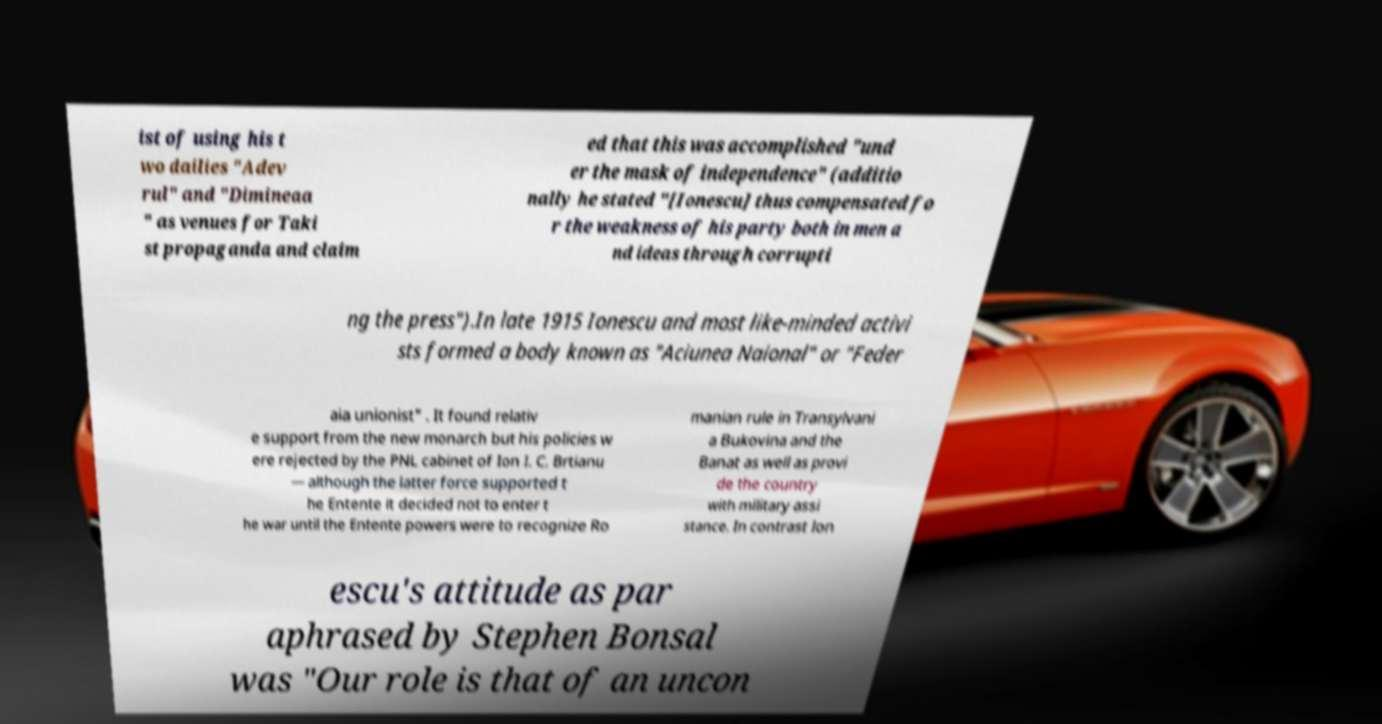Please read and relay the text visible in this image. What does it say? ist of using his t wo dailies "Adev rul" and "Dimineaa " as venues for Taki st propaganda and claim ed that this was accomplished "und er the mask of independence" (additio nally he stated "[Ionescu] thus compensated fo r the weakness of his party both in men a nd ideas through corrupti ng the press").In late 1915 Ionescu and most like-minded activi sts formed a body known as "Aciunea Naional" or "Feder aia unionist" . It found relativ e support from the new monarch but his policies w ere rejected by the PNL cabinet of Ion I. C. Brtianu — although the latter force supported t he Entente it decided not to enter t he war until the Entente powers were to recognize Ro manian rule in Transylvani a Bukovina and the Banat as well as provi de the country with military assi stance. In contrast Ion escu's attitude as par aphrased by Stephen Bonsal was "Our role is that of an uncon 